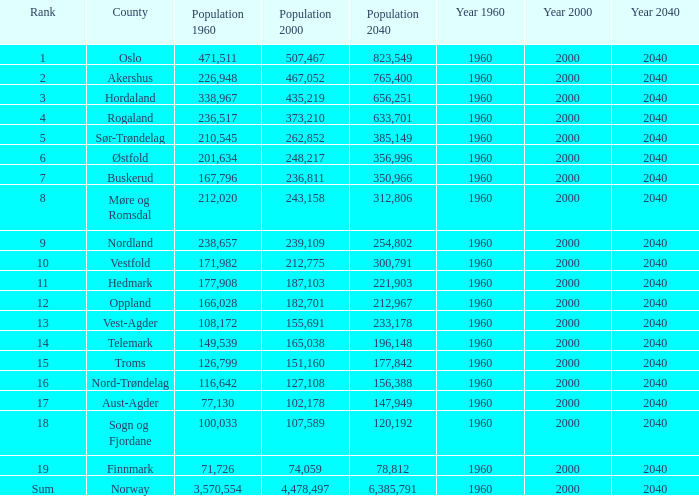What was the population of a county in 2040 that had a population less than 108,172 in 2000 and less than 107,589 in 1960? 2.0. 